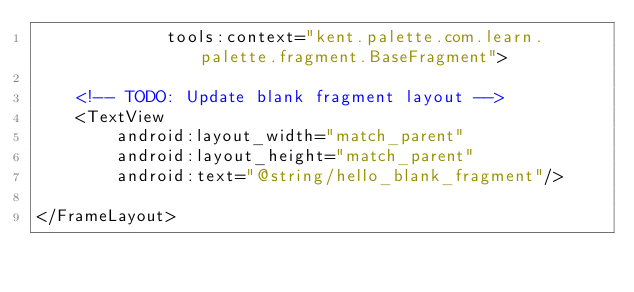Convert code to text. <code><loc_0><loc_0><loc_500><loc_500><_XML_>             tools:context="kent.palette.com.learn.palette.fragment.BaseFragment">

    <!-- TODO: Update blank fragment layout -->
    <TextView
        android:layout_width="match_parent"
        android:layout_height="match_parent"
        android:text="@string/hello_blank_fragment"/>

</FrameLayout>
</code> 